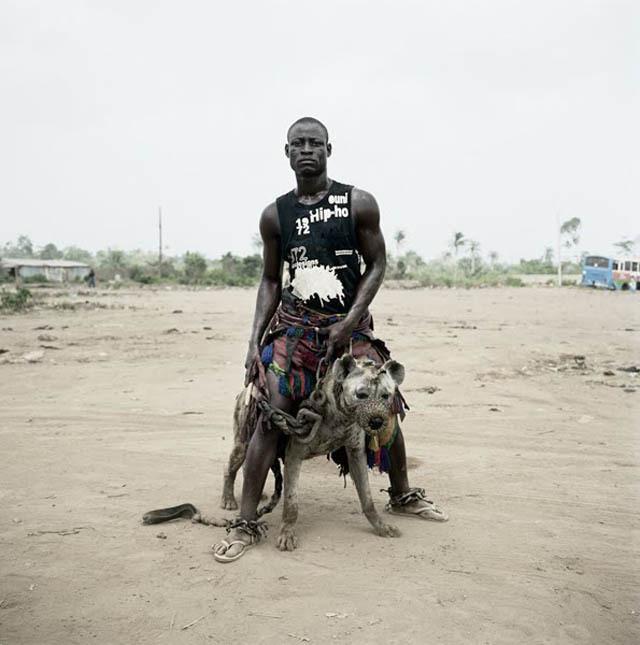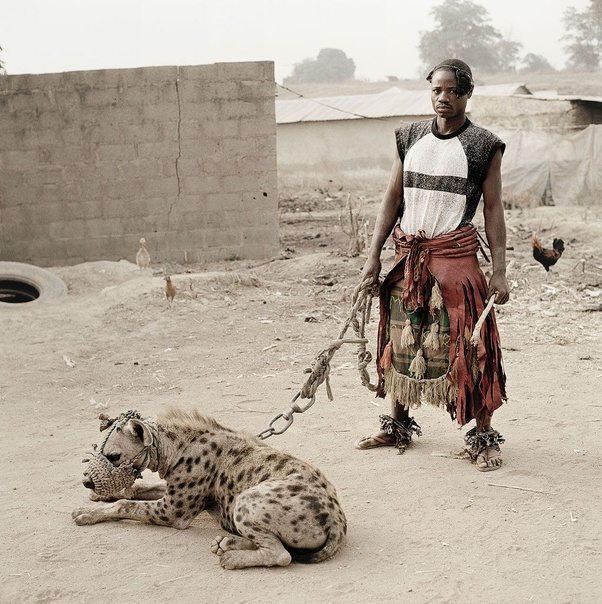The first image is the image on the left, the second image is the image on the right. Evaluate the accuracy of this statement regarding the images: "There are at least two people in the image on the right.". Is it true? Answer yes or no. No. The first image is the image on the left, the second image is the image on the right. Analyze the images presented: Is the assertion "An image shows a man standing with a hyena that is on all fours." valid? Answer yes or no. Yes. 